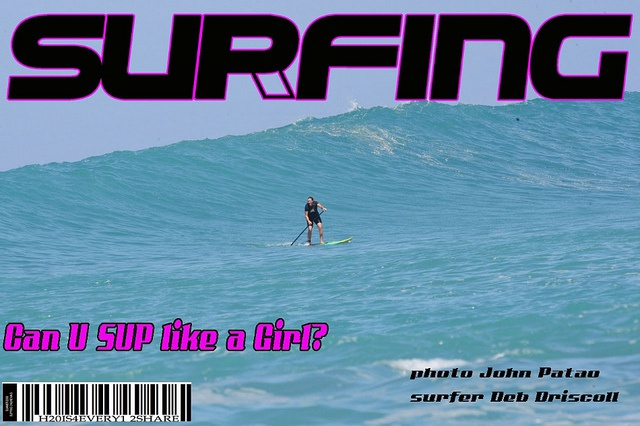Describe the objects in this image and their specific colors. I can see people in darkgray, black, and gray tones, surfboard in darkgray, turquoise, aquamarine, and lightgreen tones, and surfboard in darkgray, gray, lightblue, and blue tones in this image. 